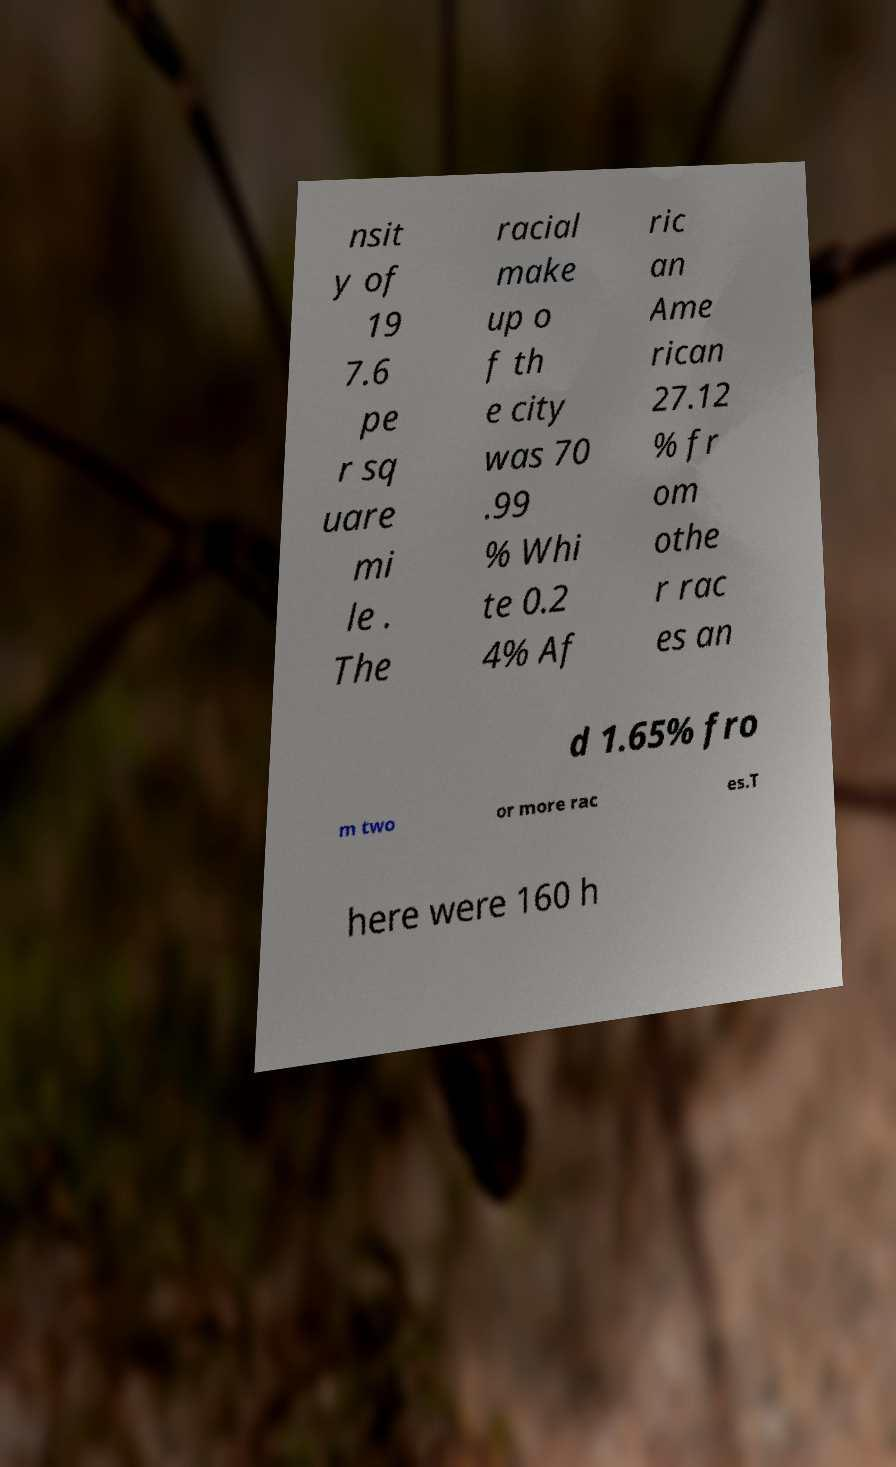Can you accurately transcribe the text from the provided image for me? nsit y of 19 7.6 pe r sq uare mi le . The racial make up o f th e city was 70 .99 % Whi te 0.2 4% Af ric an Ame rican 27.12 % fr om othe r rac es an d 1.65% fro m two or more rac es.T here were 160 h 